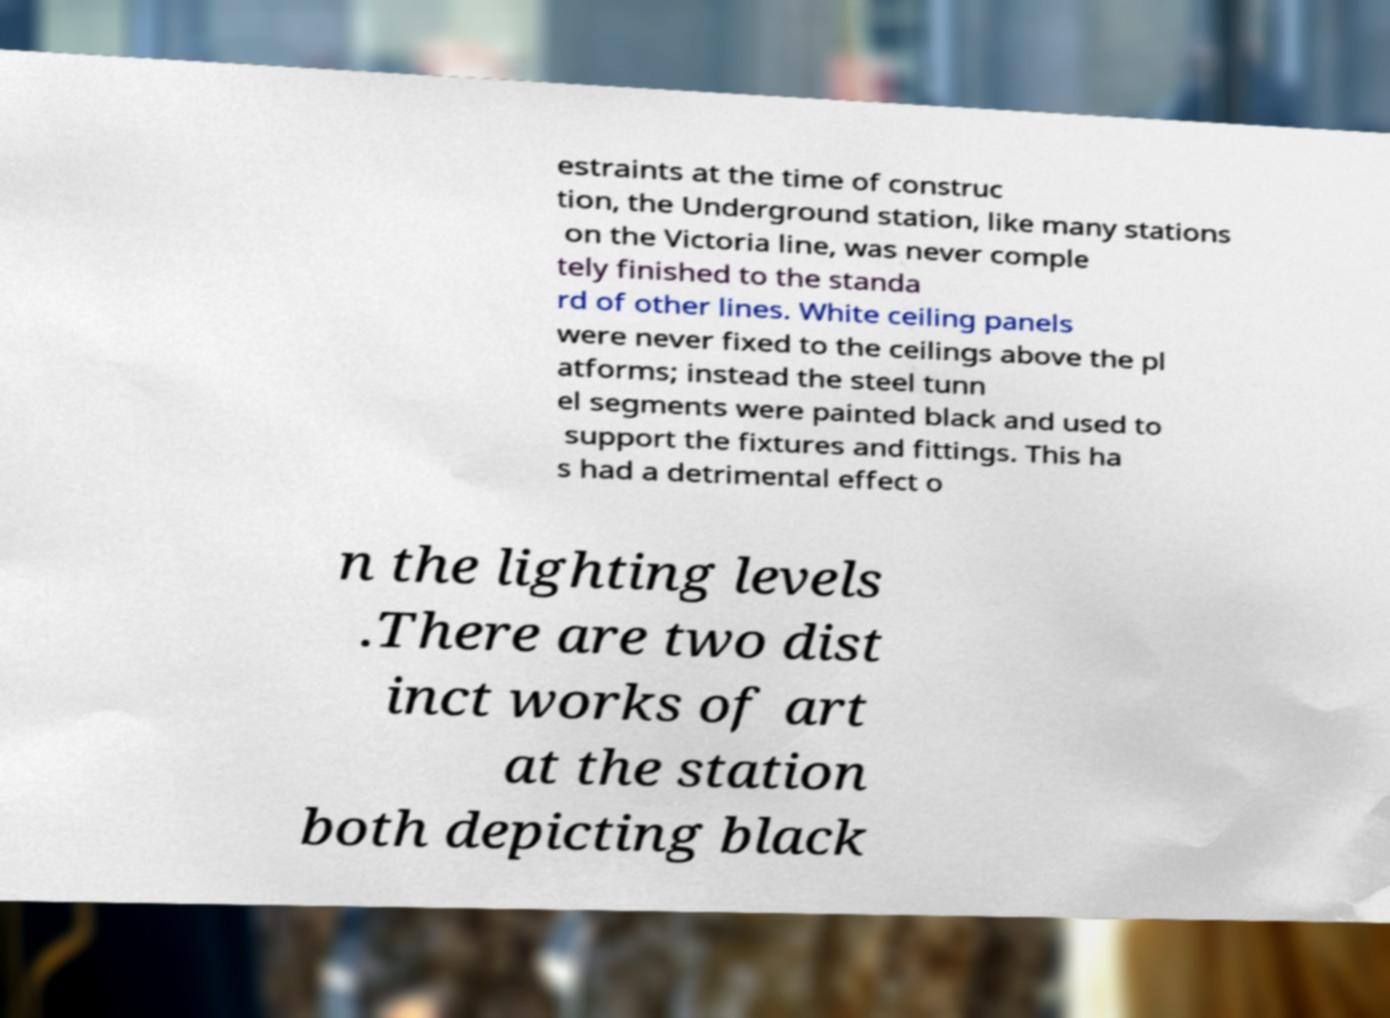I need the written content from this picture converted into text. Can you do that? estraints at the time of construc tion, the Underground station, like many stations on the Victoria line, was never comple tely finished to the standa rd of other lines. White ceiling panels were never fixed to the ceilings above the pl atforms; instead the steel tunn el segments were painted black and used to support the fixtures and fittings. This ha s had a detrimental effect o n the lighting levels .There are two dist inct works of art at the station both depicting black 